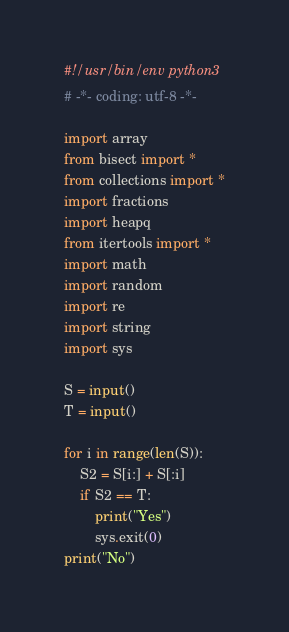<code> <loc_0><loc_0><loc_500><loc_500><_Python_>#!/usr/bin/env python3
# -*- coding: utf-8 -*-

import array
from bisect import *
from collections import *
import fractions
import heapq 
from itertools import *
import math
import random
import re
import string
import sys

S = input()
T = input()

for i in range(len(S)):
    S2 = S[i:] + S[:i]
    if S2 == T:
        print("Yes")
        sys.exit(0)
print("No")

</code> 